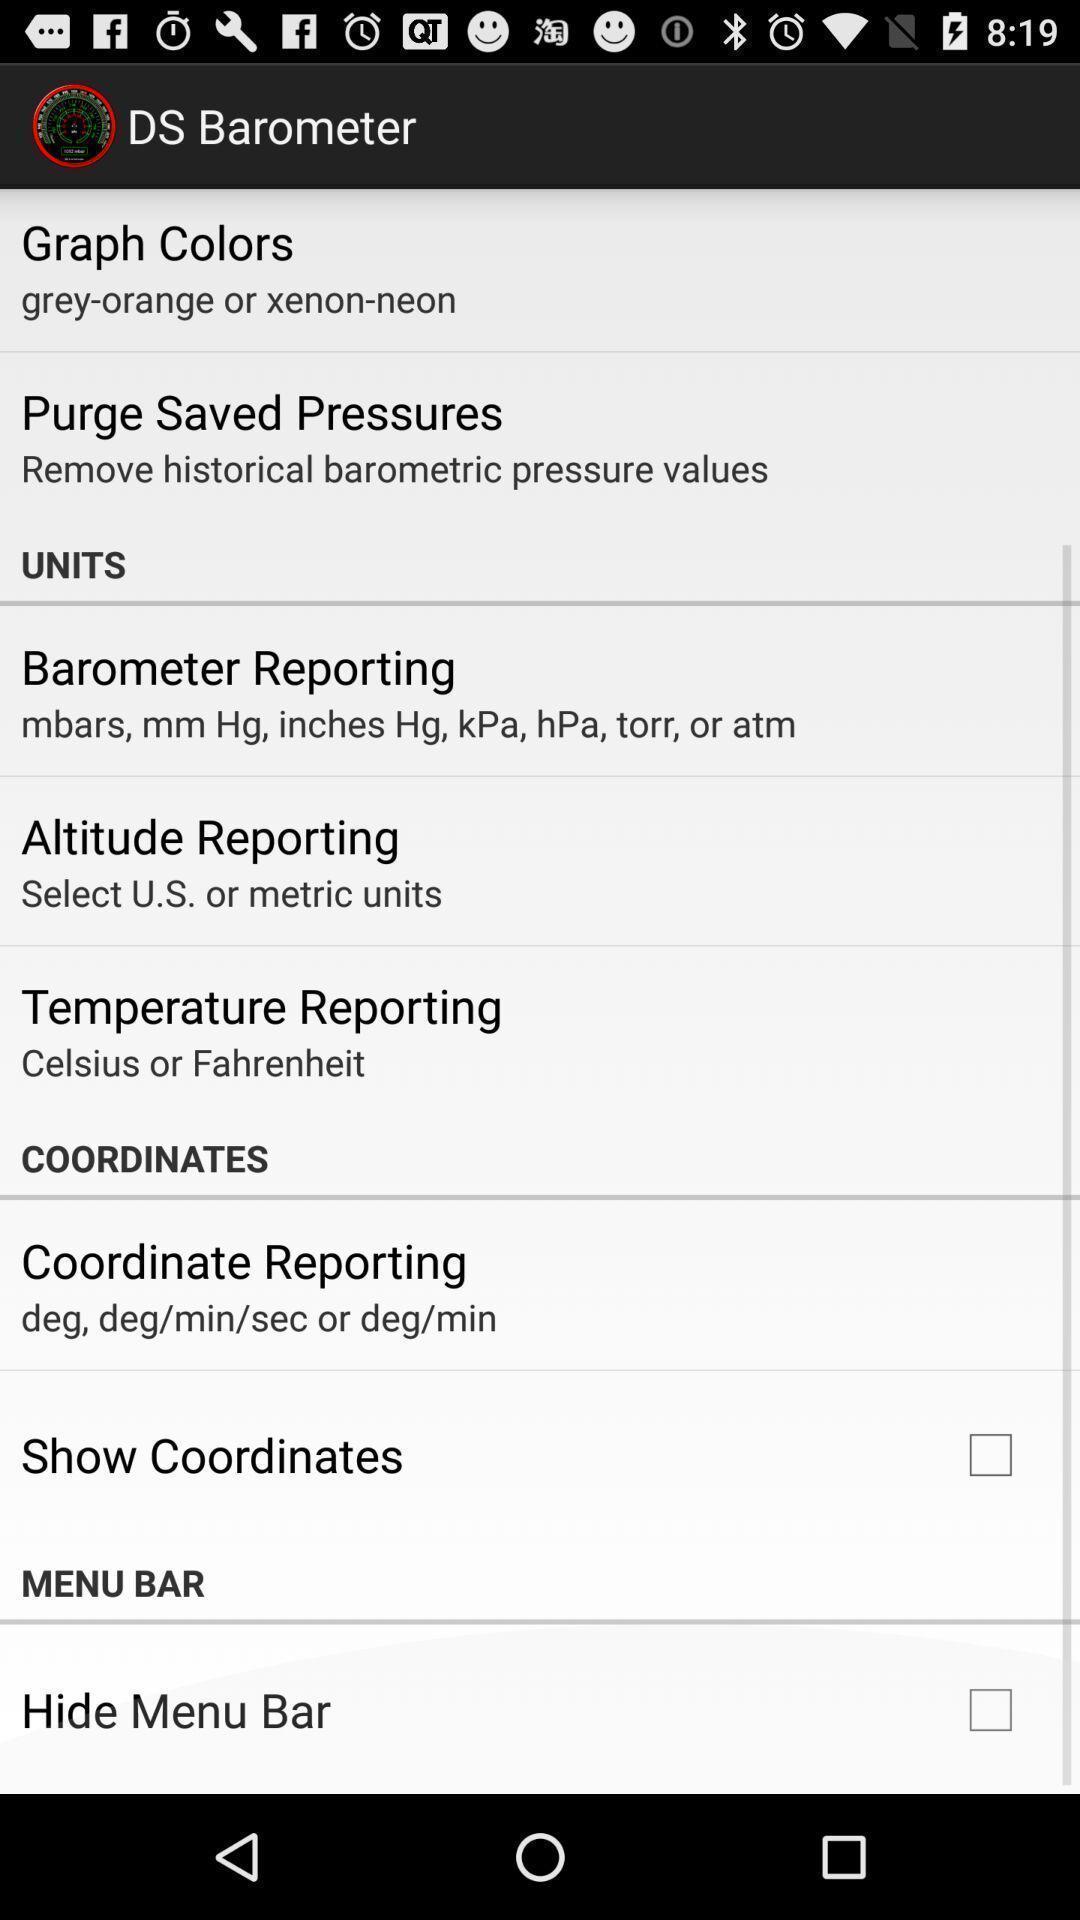What is the overall content of this screenshot? Various options displayed of an sensor app. 